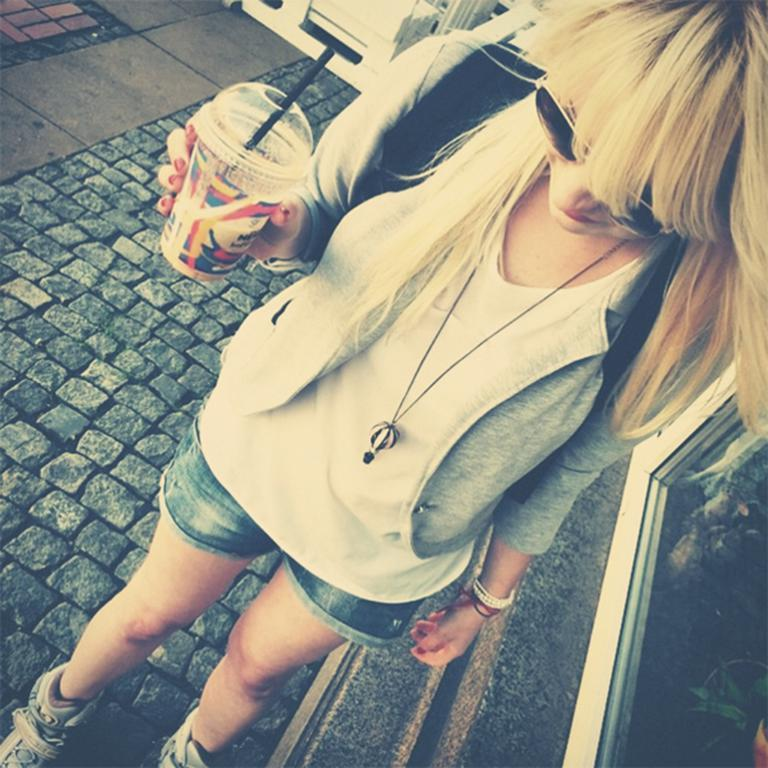Who is present in the image? There is a woman in the image. What is the woman doing in the image? The woman is standing on a path. What is the woman holding in the image? The woman is holding a cup. What is inside the cup? There is a straw in the cup. What can be seen on the right side of the woman? There is a window on the right side of the woman. How many scarecrows are visible in the image? There are no scarecrows present in the image. What type of cats can be seen playing near the woman in the image? There are no cats present in the image. 